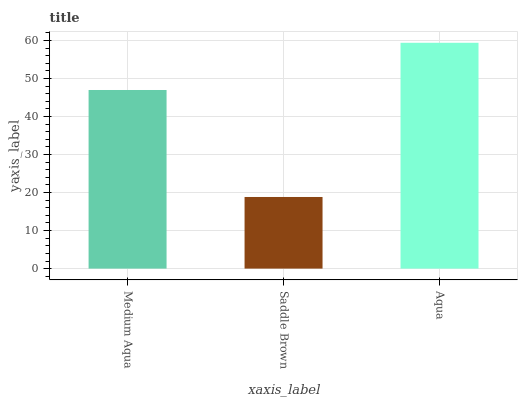Is Saddle Brown the minimum?
Answer yes or no. Yes. Is Aqua the maximum?
Answer yes or no. Yes. Is Aqua the minimum?
Answer yes or no. No. Is Saddle Brown the maximum?
Answer yes or no. No. Is Aqua greater than Saddle Brown?
Answer yes or no. Yes. Is Saddle Brown less than Aqua?
Answer yes or no. Yes. Is Saddle Brown greater than Aqua?
Answer yes or no. No. Is Aqua less than Saddle Brown?
Answer yes or no. No. Is Medium Aqua the high median?
Answer yes or no. Yes. Is Medium Aqua the low median?
Answer yes or no. Yes. Is Aqua the high median?
Answer yes or no. No. Is Aqua the low median?
Answer yes or no. No. 